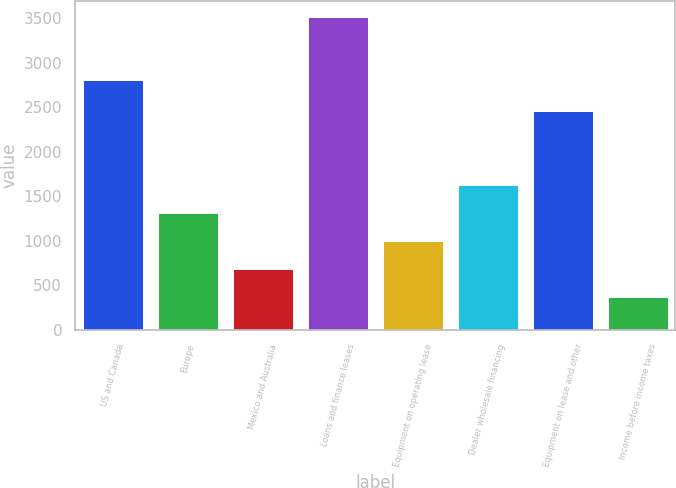Convert chart. <chart><loc_0><loc_0><loc_500><loc_500><bar_chart><fcel>US and Canada<fcel>Europe<fcel>Mexico and Australia<fcel>Loans and finance leases<fcel>Equipment on operating lease<fcel>Dealer wholesale financing<fcel>Equipment on lease and other<fcel>Income before income taxes<nl><fcel>2798.3<fcel>1314.29<fcel>685.03<fcel>3516.7<fcel>999.66<fcel>1628.92<fcel>2452.9<fcel>370.4<nl></chart> 